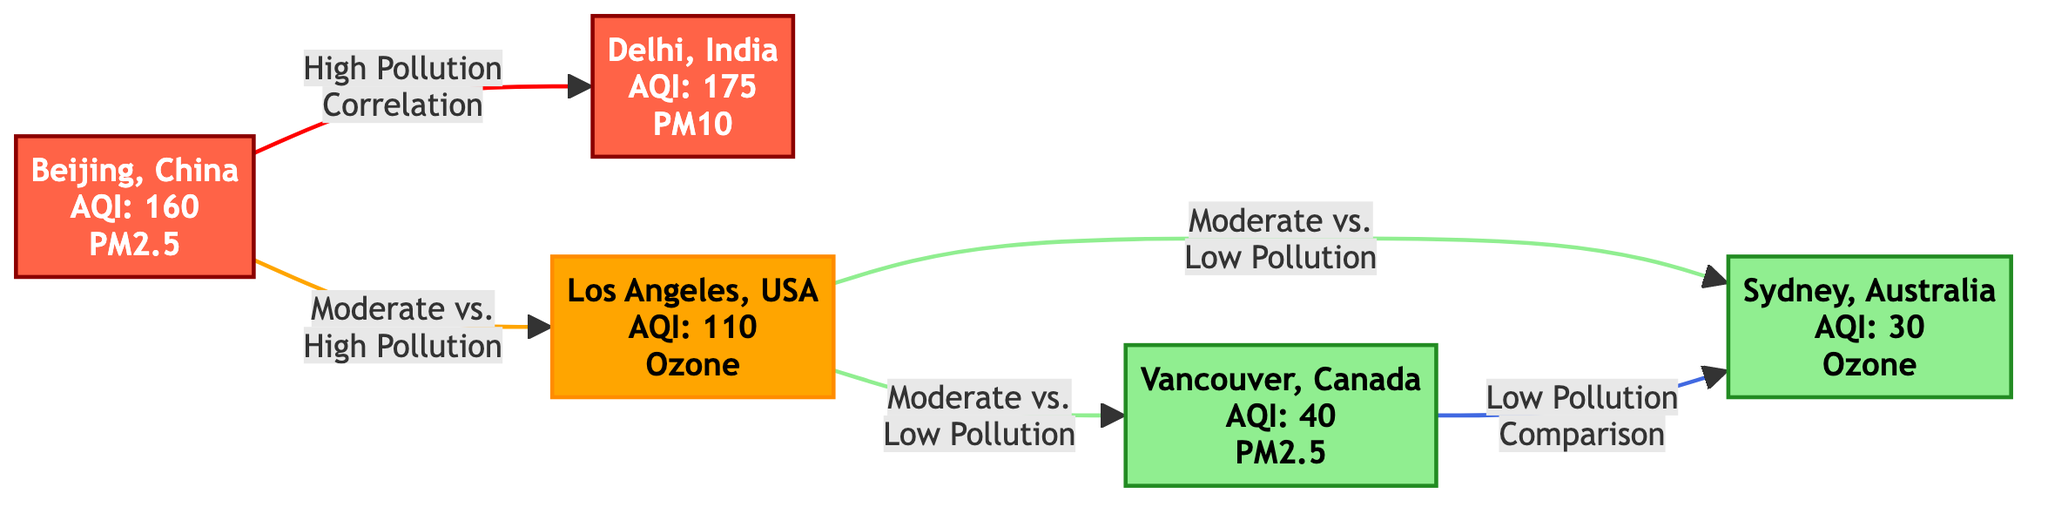What city has the highest AQI? The diagram indicates that Delhi, India has the highest AQI value of 175. By looking at the nodes, Delhi is marked under Andromeda, which displays the AQI value clearly.
Answer: Delhi, India What is the AQI value of Sydney, Australia? In the diagram, Sydney, Australia is represented with an AQI value of 30, as shown in the Sirius node.
Answer: 30 Which cities are classified under low pollution? The diagram shows two cities classified under low pollution: Vancouver, Canada and Sydney, Australia. This is determined by their color coding in the diagram, with Pleiades and Sirius marked in green.
Answer: Vancouver, Canada and Sydney, Australia How many cities are identified in the diagram? The diagram identifies a total of five cities (nodes): Beijing, Delhi, Los Angeles, Vancouver, and Sydney. By counting the nodes depicted, we find five distinct locations.
Answer: 5 Which city compares moderate and low pollution? The city that compares moderate versus low pollution is indicated as Los Angeles, USA, represented by the Orion Nebula node. This is shown by the direct connections linking OrionNebula to Pleiades and Sirius.
Answer: Los Angeles, USA What pollution level is indicated for Beijing, China? The diagram indicates that Beijing, China has a high pollution level, classified under highPollution with AQI 160. This can be understood through the color coding and labels in the diagram.
Answer: High pollution Which two cities have a direct comparison link in the diagram? The cities with a direct comparison link are Los Angeles, USA and Vancouver, Canada, as indicated by the connections illustrated in the diagram. Specifically, they are linked through the OrionNebula to Pleiades pathway.
Answer: Los Angeles, USA and Vancouver, Canada What is the relationship type between Beijing and Delhi? The relationship type between Beijing and Delhi is classified as high pollution correlation. This is indicated by the label on the arrow connecting these two nodes in the diagram.
Answer: High Pollution Correlation What is the pollution classification of Vancouver, Canada? Vancouver, Canada is classified under low pollution in the diagram, as shown by its color coding and AQI value of 40. This information can be found in the Pleiades node.
Answer: Low pollution 